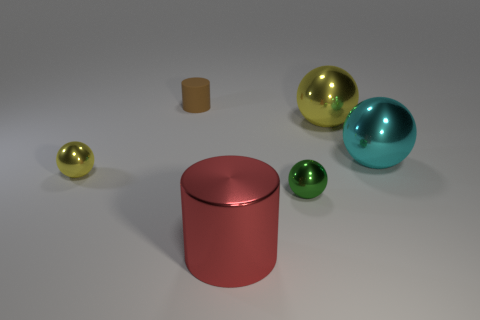What materials seem to compose the objects in this image? The objects in this image appear to be rendered with different materials that give off shiny and matte finishes, suggesting a digital representation of metals and perhaps plastic. The sphere and cylindrical shapes have reflective surfaces consistent with metallic properties, while the tiny cube looks like it may have a non-metallic, matte finish. 